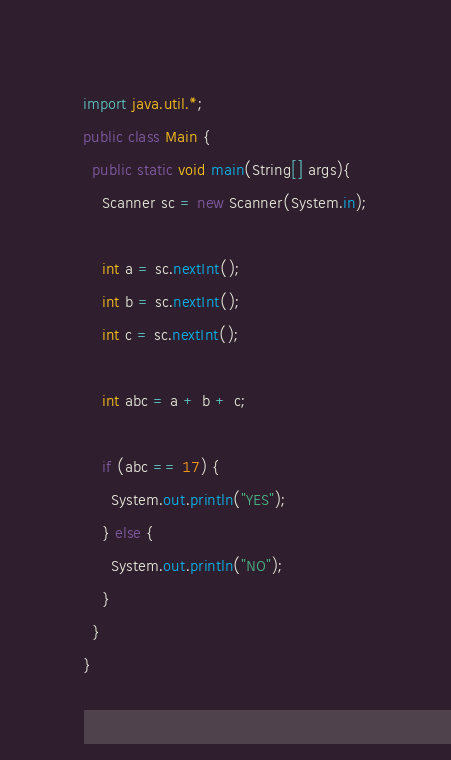Convert code to text. <code><loc_0><loc_0><loc_500><loc_500><_Java_>import java.util.*;
public class Main {
  public static void main(String[] args){
    Scanner sc = new Scanner(System.in);
    
    int a = sc.nextInt();
    int b = sc.nextInt();
    int c = sc.nextInt();
    
    int abc = a + b + c;
    
    if (abc == 17) {
      System.out.println("YES");
    } else {
      System.out.println("NO");
    }
  }
}</code> 